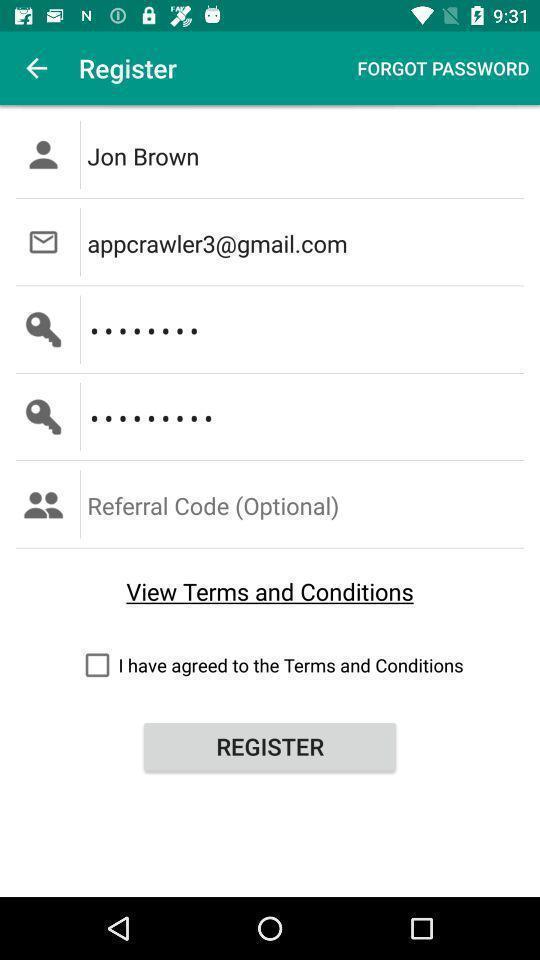Explain the elements present in this screenshot. Sign up page for a social app. 